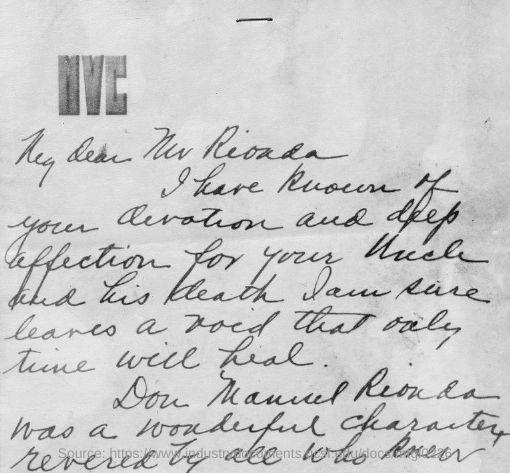Specify some key components in this picture. The top text in the document is "MVC..". 